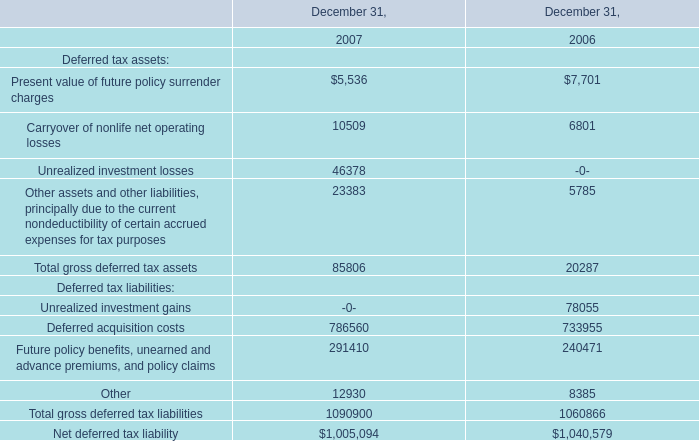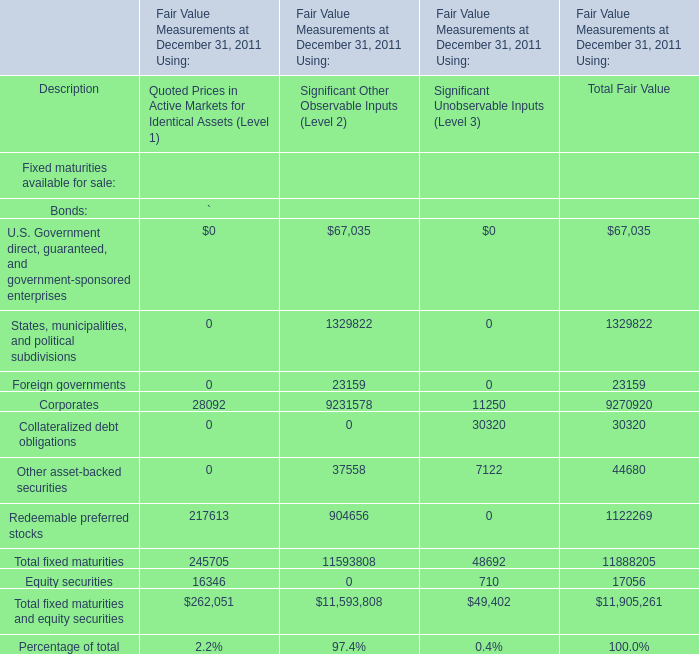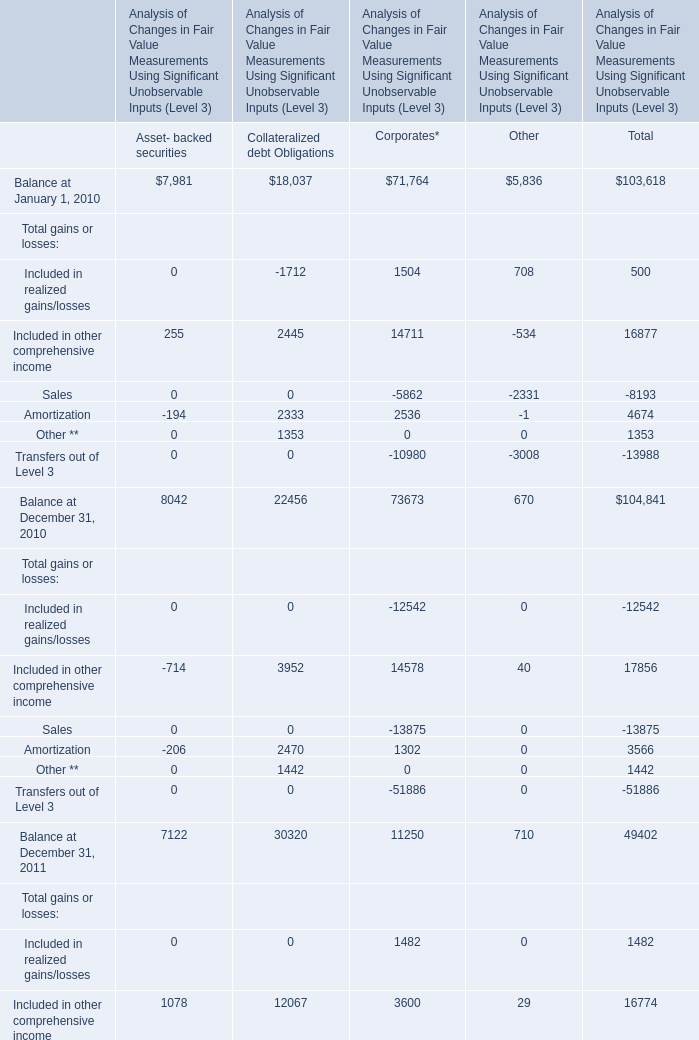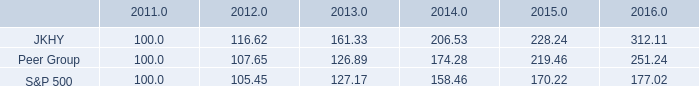Which element for Total Fair Value exceeds 10% of total in 2011? 
Answer: States, municipalities, and political subdivisions, Corporates, Redeemable preferred stocks. 